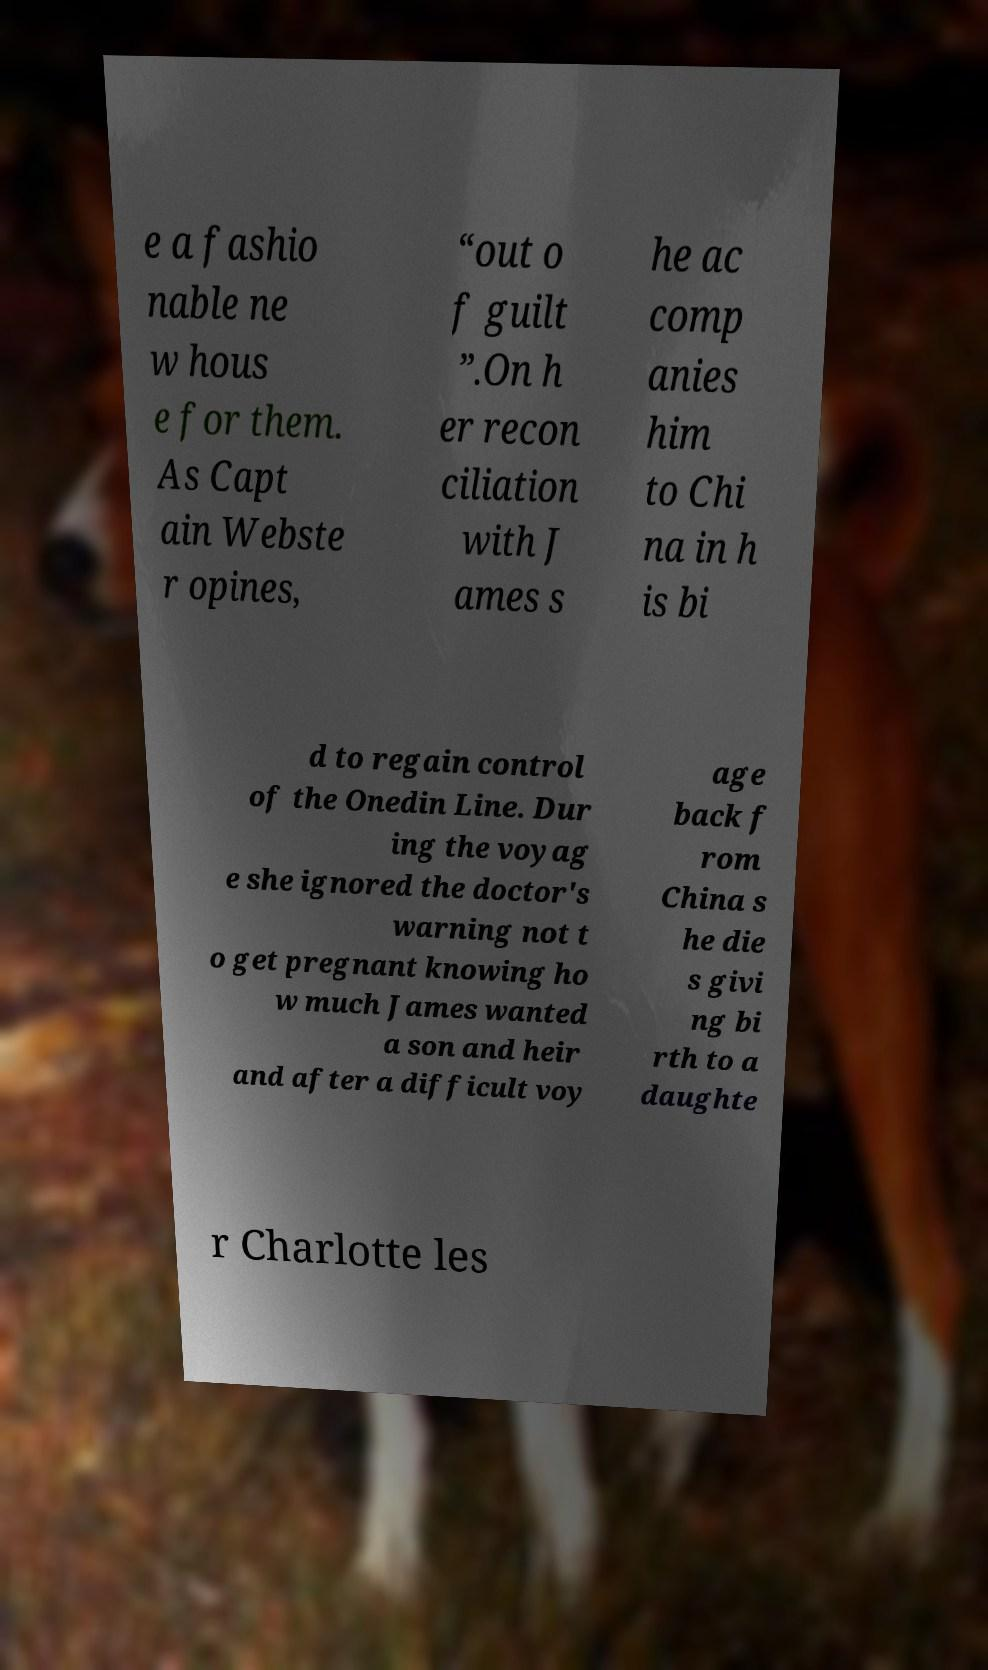I need the written content from this picture converted into text. Can you do that? e a fashio nable ne w hous e for them. As Capt ain Webste r opines, “out o f guilt ”.On h er recon ciliation with J ames s he ac comp anies him to Chi na in h is bi d to regain control of the Onedin Line. Dur ing the voyag e she ignored the doctor's warning not t o get pregnant knowing ho w much James wanted a son and heir and after a difficult voy age back f rom China s he die s givi ng bi rth to a daughte r Charlotte les 